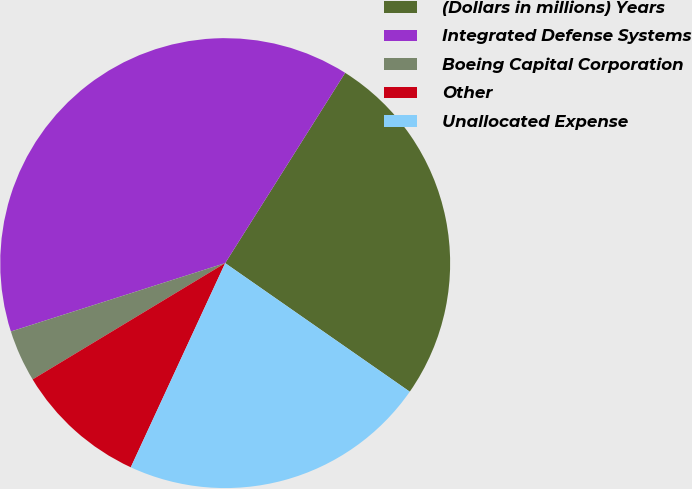Convert chart. <chart><loc_0><loc_0><loc_500><loc_500><pie_chart><fcel>(Dollars in millions) Years<fcel>Integrated Defense Systems<fcel>Boeing Capital Corporation<fcel>Other<fcel>Unallocated Expense<nl><fcel>25.73%<fcel>38.87%<fcel>3.73%<fcel>9.46%<fcel>22.21%<nl></chart> 